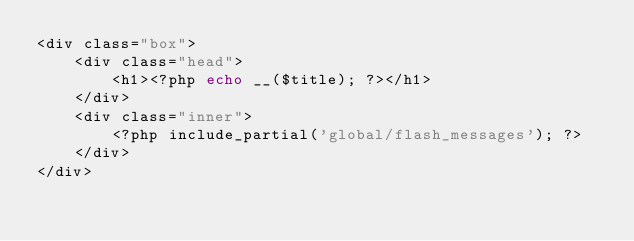Convert code to text. <code><loc_0><loc_0><loc_500><loc_500><_PHP_><div class="box">    
    <div class="head">
        <h1><?php echo __($title); ?></h1>
    </div>    
    <div class="inner">
        <?php include_partial('global/flash_messages'); ?>    
    </div>
</div></code> 